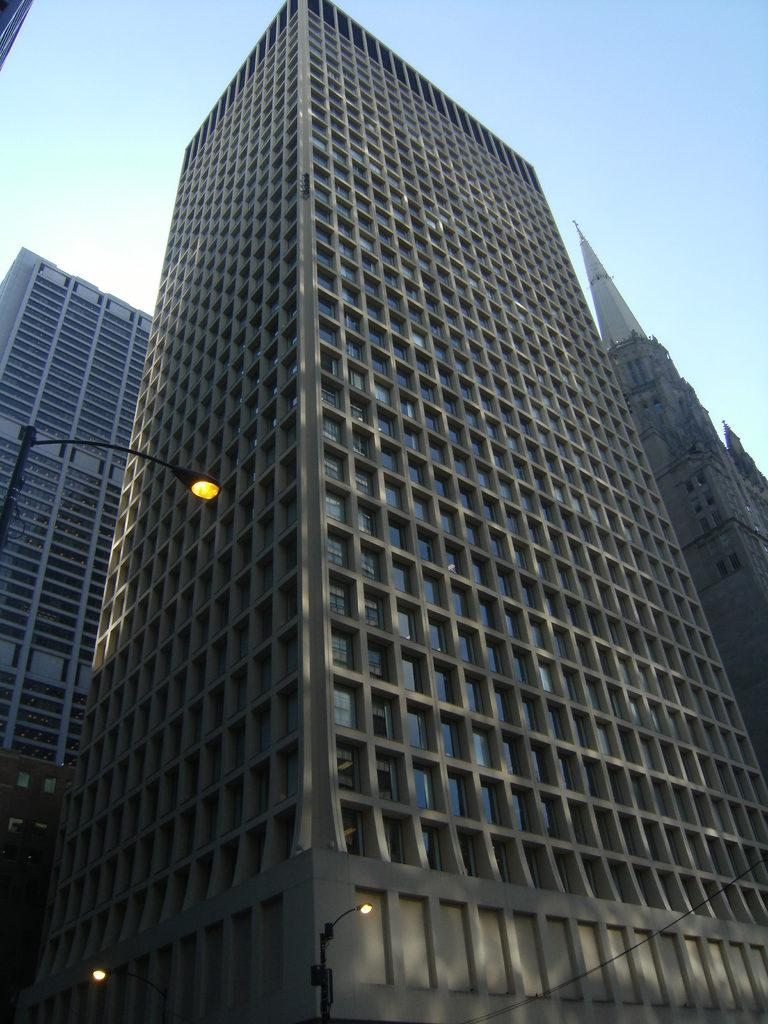What can be seen in the image? There are many buildings in the image. Where is the light pole located in the image? The light pole is on the left side of the image. What color is the sky in the background of the image? The sky is blue in the background of the image. Can you see a pipe coming out of the building in the image? There is no pipe visible in the image. Is there a face visible on the light pole in the image? There is no face visible on the light pole in the image. 